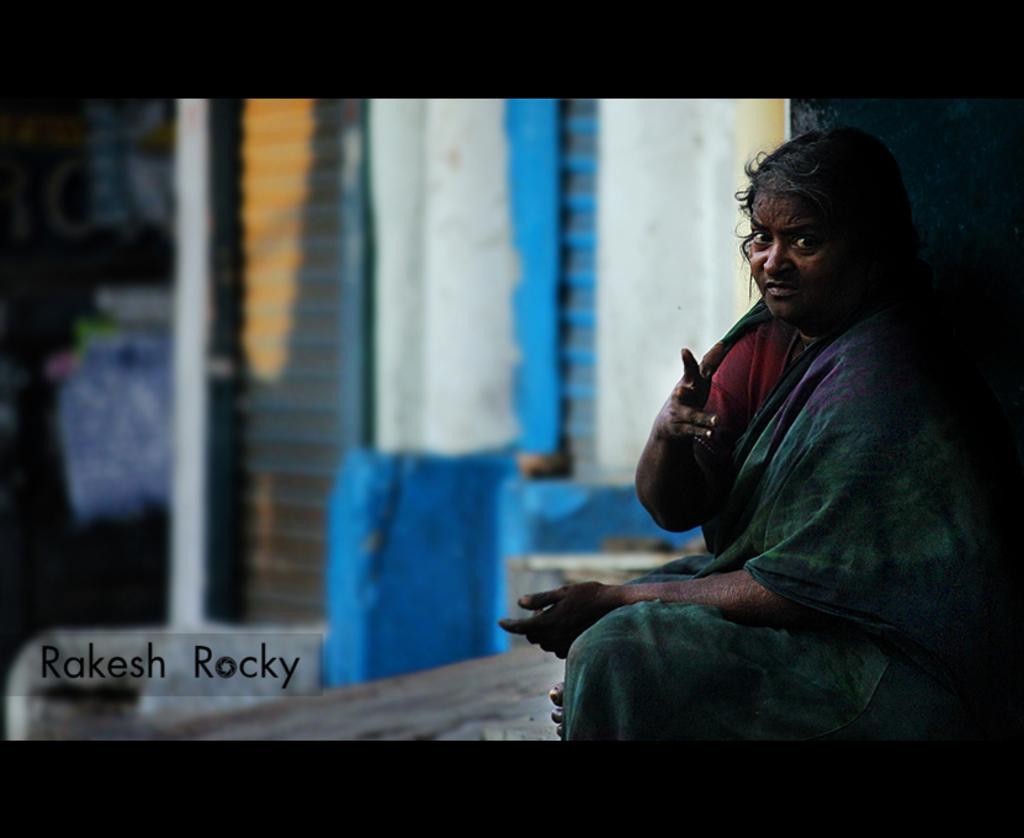Please provide a concise description of this image. In this image I can see a person sitting wearing green color saree, at the back I can see wall in blue and white color. 